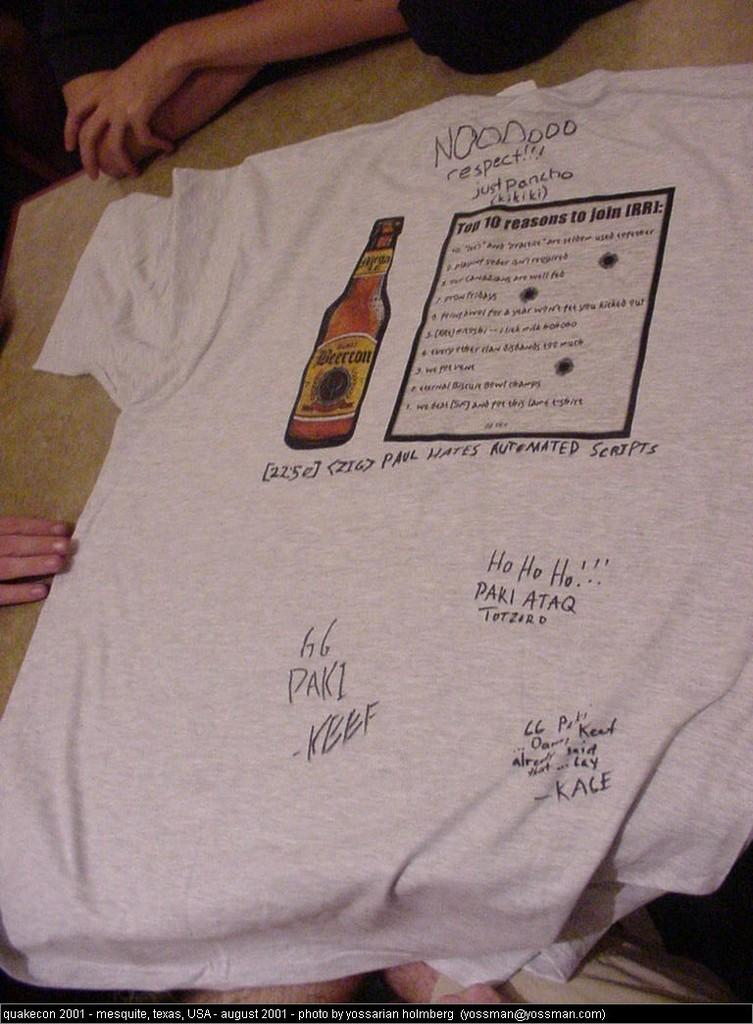What is the main object in the foreground of the image? There is a T-shirt in the foreground of the image. What is depicted on the T-shirt? A bottle and a box are printed on the T-shirt. What can be seen in the background of the image? In the background, hands and legs of persons are visible. What type of pie is being discussed by the persons in the image? There is no pie or discussion present in the image; it only features a T-shirt with a bottle and a box, and hands and legs of persons in the background. 